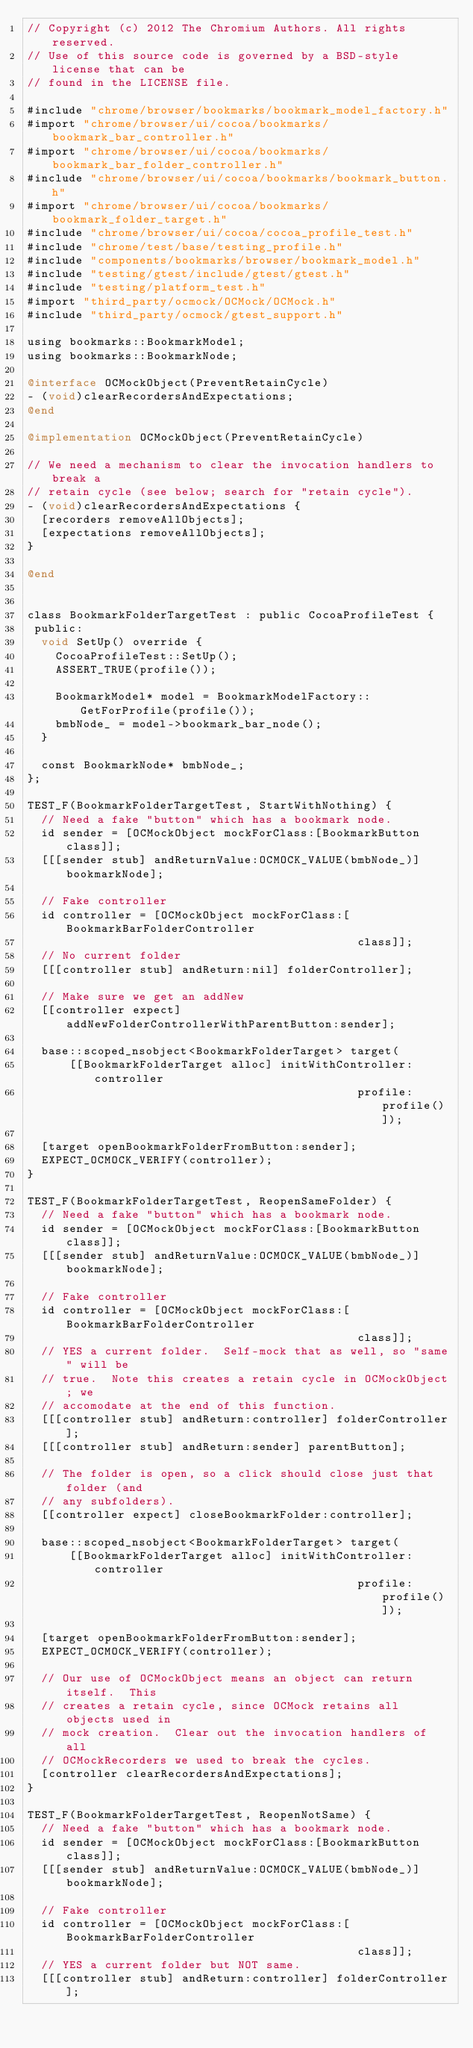Convert code to text. <code><loc_0><loc_0><loc_500><loc_500><_ObjectiveC_>// Copyright (c) 2012 The Chromium Authors. All rights reserved.
// Use of this source code is governed by a BSD-style license that can be
// found in the LICENSE file.

#include "chrome/browser/bookmarks/bookmark_model_factory.h"
#import "chrome/browser/ui/cocoa/bookmarks/bookmark_bar_controller.h"
#import "chrome/browser/ui/cocoa/bookmarks/bookmark_bar_folder_controller.h"
#include "chrome/browser/ui/cocoa/bookmarks/bookmark_button.h"
#import "chrome/browser/ui/cocoa/bookmarks/bookmark_folder_target.h"
#include "chrome/browser/ui/cocoa/cocoa_profile_test.h"
#include "chrome/test/base/testing_profile.h"
#include "components/bookmarks/browser/bookmark_model.h"
#include "testing/gtest/include/gtest/gtest.h"
#include "testing/platform_test.h"
#import "third_party/ocmock/OCMock/OCMock.h"
#include "third_party/ocmock/gtest_support.h"

using bookmarks::BookmarkModel;
using bookmarks::BookmarkNode;

@interface OCMockObject(PreventRetainCycle)
- (void)clearRecordersAndExpectations;
@end

@implementation OCMockObject(PreventRetainCycle)

// We need a mechanism to clear the invocation handlers to break a
// retain cycle (see below; search for "retain cycle").
- (void)clearRecordersAndExpectations {
  [recorders removeAllObjects];
  [expectations removeAllObjects];
}

@end


class BookmarkFolderTargetTest : public CocoaProfileTest {
 public:
  void SetUp() override {
    CocoaProfileTest::SetUp();
    ASSERT_TRUE(profile());

    BookmarkModel* model = BookmarkModelFactory::GetForProfile(profile());
    bmbNode_ = model->bookmark_bar_node();
  }

  const BookmarkNode* bmbNode_;
};

TEST_F(BookmarkFolderTargetTest, StartWithNothing) {
  // Need a fake "button" which has a bookmark node.
  id sender = [OCMockObject mockForClass:[BookmarkButton class]];
  [[[sender stub] andReturnValue:OCMOCK_VALUE(bmbNode_)] bookmarkNode];

  // Fake controller
  id controller = [OCMockObject mockForClass:[BookmarkBarFolderController
                                               class]];
  // No current folder
  [[[controller stub] andReturn:nil] folderController];

  // Make sure we get an addNew
  [[controller expect] addNewFolderControllerWithParentButton:sender];

  base::scoped_nsobject<BookmarkFolderTarget> target(
      [[BookmarkFolderTarget alloc] initWithController:controller
                                               profile:profile()]);

  [target openBookmarkFolderFromButton:sender];
  EXPECT_OCMOCK_VERIFY(controller);
}

TEST_F(BookmarkFolderTargetTest, ReopenSameFolder) {
  // Need a fake "button" which has a bookmark node.
  id sender = [OCMockObject mockForClass:[BookmarkButton class]];
  [[[sender stub] andReturnValue:OCMOCK_VALUE(bmbNode_)] bookmarkNode];

  // Fake controller
  id controller = [OCMockObject mockForClass:[BookmarkBarFolderController
                                               class]];
  // YES a current folder.  Self-mock that as well, so "same" will be
  // true.  Note this creates a retain cycle in OCMockObject; we
  // accomodate at the end of this function.
  [[[controller stub] andReturn:controller] folderController];
  [[[controller stub] andReturn:sender] parentButton];

  // The folder is open, so a click should close just that folder (and
  // any subfolders).
  [[controller expect] closeBookmarkFolder:controller];

  base::scoped_nsobject<BookmarkFolderTarget> target(
      [[BookmarkFolderTarget alloc] initWithController:controller
                                               profile:profile()]);

  [target openBookmarkFolderFromButton:sender];
  EXPECT_OCMOCK_VERIFY(controller);

  // Our use of OCMockObject means an object can return itself.  This
  // creates a retain cycle, since OCMock retains all objects used in
  // mock creation.  Clear out the invocation handlers of all
  // OCMockRecorders we used to break the cycles.
  [controller clearRecordersAndExpectations];
}

TEST_F(BookmarkFolderTargetTest, ReopenNotSame) {
  // Need a fake "button" which has a bookmark node.
  id sender = [OCMockObject mockForClass:[BookmarkButton class]];
  [[[sender stub] andReturnValue:OCMOCK_VALUE(bmbNode_)] bookmarkNode];

  // Fake controller
  id controller = [OCMockObject mockForClass:[BookmarkBarFolderController
                                               class]];
  // YES a current folder but NOT same.
  [[[controller stub] andReturn:controller] folderController];</code> 